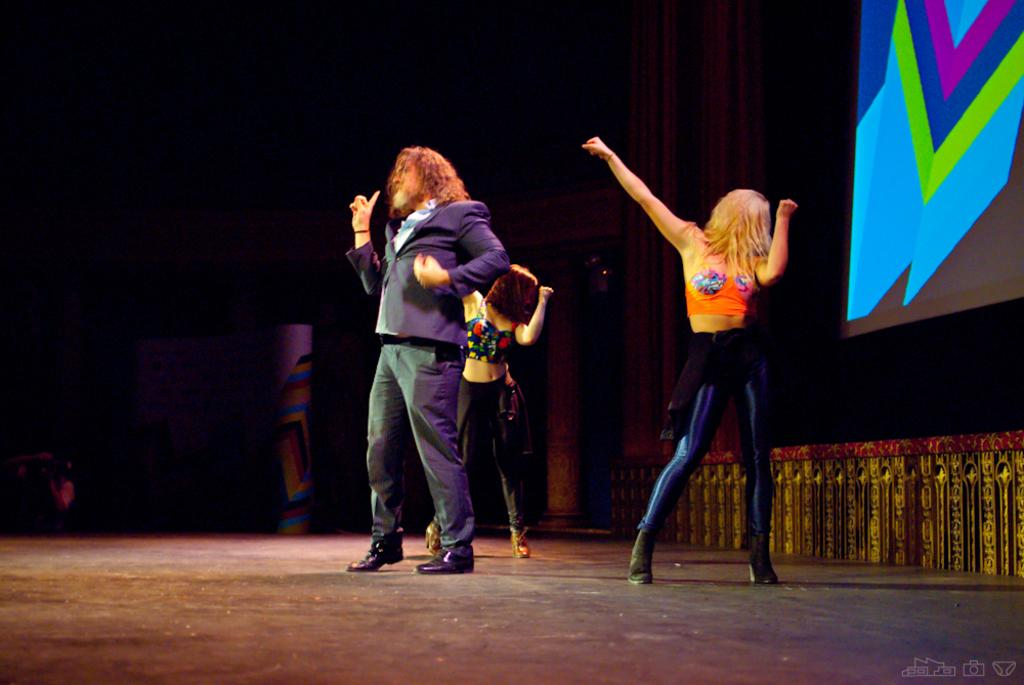How many people are in the image? There are two women and a man standing in the image, making a total of three people. What are the individuals wearing? The individuals are wearing clothes and shoes. What can be seen on the floor in the image? There is a projected screen on the floor in the image. What is the condition of the background in the image? The background of the image is blurred. What is the reason the brother is not present in the image? There is no mention of a brother in the image or the provided facts, so it is not possible to determine the reason for their absence. 